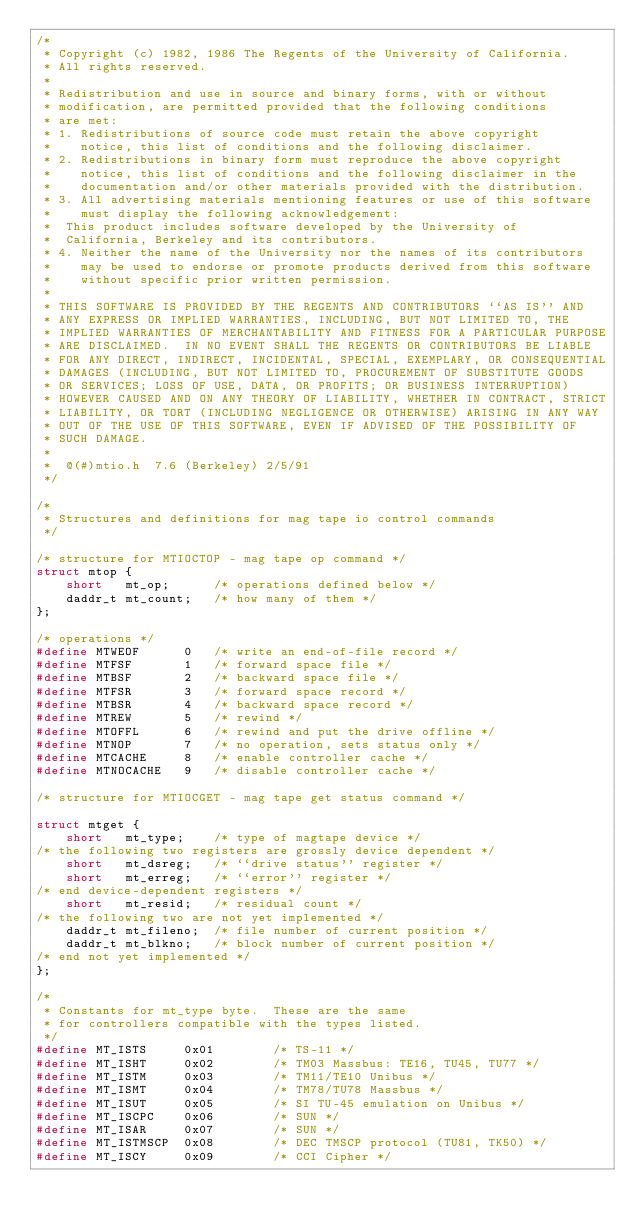<code> <loc_0><loc_0><loc_500><loc_500><_C_>/*
 * Copyright (c) 1982, 1986 The Regents of the University of California.
 * All rights reserved.
 *
 * Redistribution and use in source and binary forms, with or without
 * modification, are permitted provided that the following conditions
 * are met:
 * 1. Redistributions of source code must retain the above copyright
 *    notice, this list of conditions and the following disclaimer.
 * 2. Redistributions in binary form must reproduce the above copyright
 *    notice, this list of conditions and the following disclaimer in the
 *    documentation and/or other materials provided with the distribution.
 * 3. All advertising materials mentioning features or use of this software
 *    must display the following acknowledgement:
 *	This product includes software developed by the University of
 *	California, Berkeley and its contributors.
 * 4. Neither the name of the University nor the names of its contributors
 *    may be used to endorse or promote products derived from this software
 *    without specific prior written permission.
 *
 * THIS SOFTWARE IS PROVIDED BY THE REGENTS AND CONTRIBUTORS ``AS IS'' AND
 * ANY EXPRESS OR IMPLIED WARRANTIES, INCLUDING, BUT NOT LIMITED TO, THE
 * IMPLIED WARRANTIES OF MERCHANTABILITY AND FITNESS FOR A PARTICULAR PURPOSE
 * ARE DISCLAIMED.  IN NO EVENT SHALL THE REGENTS OR CONTRIBUTORS BE LIABLE
 * FOR ANY DIRECT, INDIRECT, INCIDENTAL, SPECIAL, EXEMPLARY, OR CONSEQUENTIAL
 * DAMAGES (INCLUDING, BUT NOT LIMITED TO, PROCUREMENT OF SUBSTITUTE GOODS
 * OR SERVICES; LOSS OF USE, DATA, OR PROFITS; OR BUSINESS INTERRUPTION)
 * HOWEVER CAUSED AND ON ANY THEORY OF LIABILITY, WHETHER IN CONTRACT, STRICT
 * LIABILITY, OR TORT (INCLUDING NEGLIGENCE OR OTHERWISE) ARISING IN ANY WAY
 * OUT OF THE USE OF THIS SOFTWARE, EVEN IF ADVISED OF THE POSSIBILITY OF
 * SUCH DAMAGE.
 *
 *	@(#)mtio.h	7.6 (Berkeley) 2/5/91
 */

/*
 * Structures and definitions for mag tape io control commands
 */

/* structure for MTIOCTOP - mag tape op command */
struct mtop {
	short	mt_op;		/* operations defined below */
	daddr_t	mt_count;	/* how many of them */
};

/* operations */
#define MTWEOF		0	/* write an end-of-file record */
#define MTFSF		1	/* forward space file */
#define MTBSF		2	/* backward space file */
#define MTFSR		3	/* forward space record */
#define MTBSR		4	/* backward space record */
#define MTREW		5	/* rewind */
#define MTOFFL		6	/* rewind and put the drive offline */
#define MTNOP		7	/* no operation, sets status only */
#define MTCACHE		8	/* enable controller cache */
#define MTNOCACHE	9	/* disable controller cache */

/* structure for MTIOCGET - mag tape get status command */

struct mtget {
	short	mt_type;	/* type of magtape device */
/* the following two registers are grossly device dependent */
	short	mt_dsreg;	/* ``drive status'' register */
	short	mt_erreg;	/* ``error'' register */
/* end device-dependent registers */
	short	mt_resid;	/* residual count */
/* the following two are not yet implemented */
	daddr_t	mt_fileno;	/* file number of current position */
	daddr_t	mt_blkno;	/* block number of current position */
/* end not yet implemented */
};

/*
 * Constants for mt_type byte.  These are the same
 * for controllers compatible with the types listed.
 */
#define	MT_ISTS		0x01		/* TS-11 */
#define	MT_ISHT		0x02		/* TM03 Massbus: TE16, TU45, TU77 */
#define	MT_ISTM		0x03		/* TM11/TE10 Unibus */
#define	MT_ISMT		0x04		/* TM78/TU78 Massbus */
#define	MT_ISUT		0x05		/* SI TU-45 emulation on Unibus */
#define	MT_ISCPC	0x06		/* SUN */
#define	MT_ISAR		0x07		/* SUN */
#define	MT_ISTMSCP	0x08		/* DEC TMSCP protocol (TU81, TK50) */
#define MT_ISCY		0x09		/* CCI Cipher */</code> 